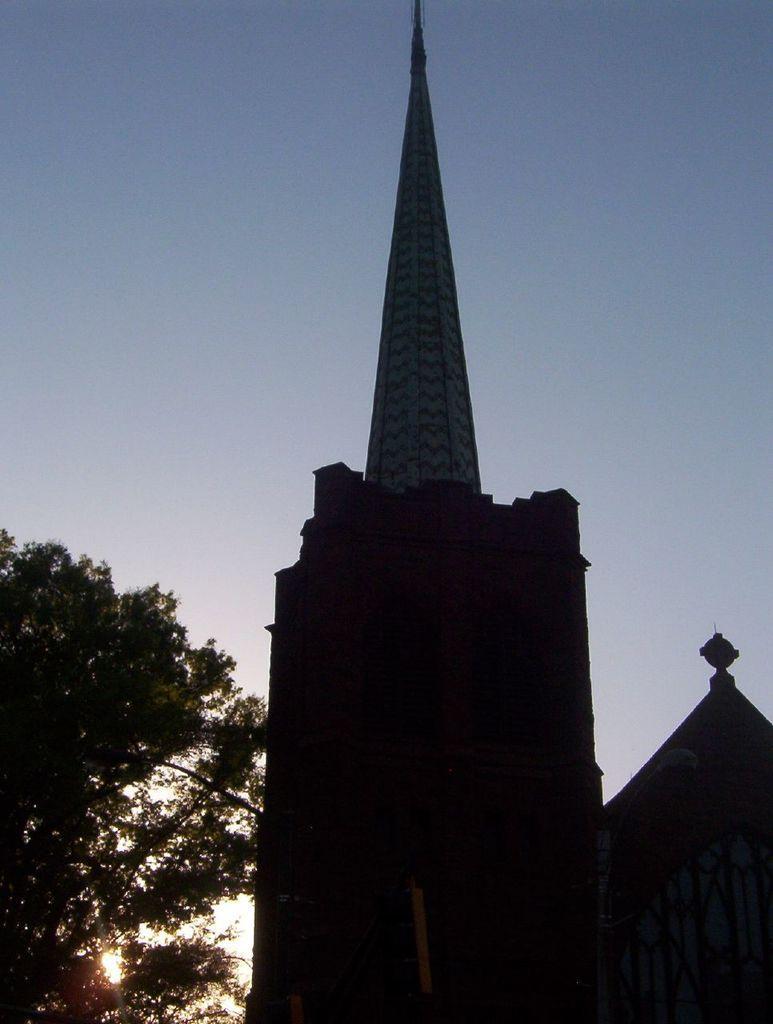Could you give a brief overview of what you see in this image? In this picture I can see a building and trees on the left side and I can see blue sky. 